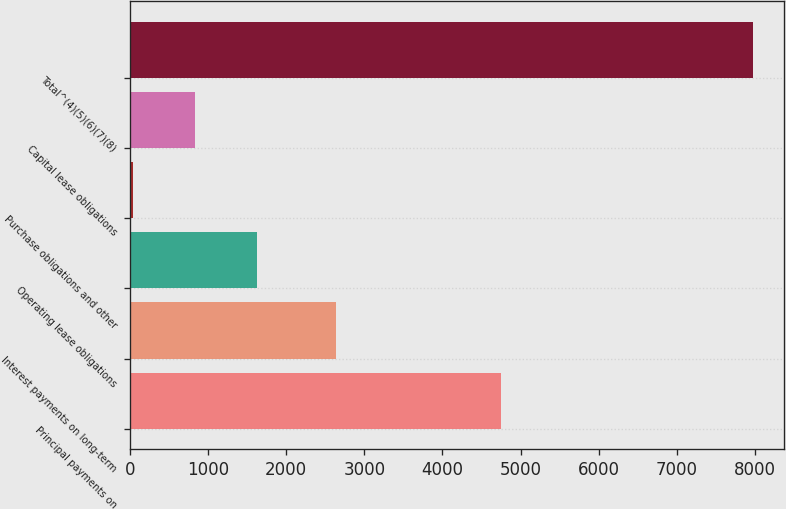Convert chart. <chart><loc_0><loc_0><loc_500><loc_500><bar_chart><fcel>Principal payments on<fcel>Interest payments on long-term<fcel>Operating lease obligations<fcel>Purchase obligations and other<fcel>Capital lease obligations<fcel>Total^(4)(5)(6)(7)(8)<nl><fcel>4750<fcel>2633<fcel>1628<fcel>41<fcel>834.5<fcel>7976<nl></chart> 